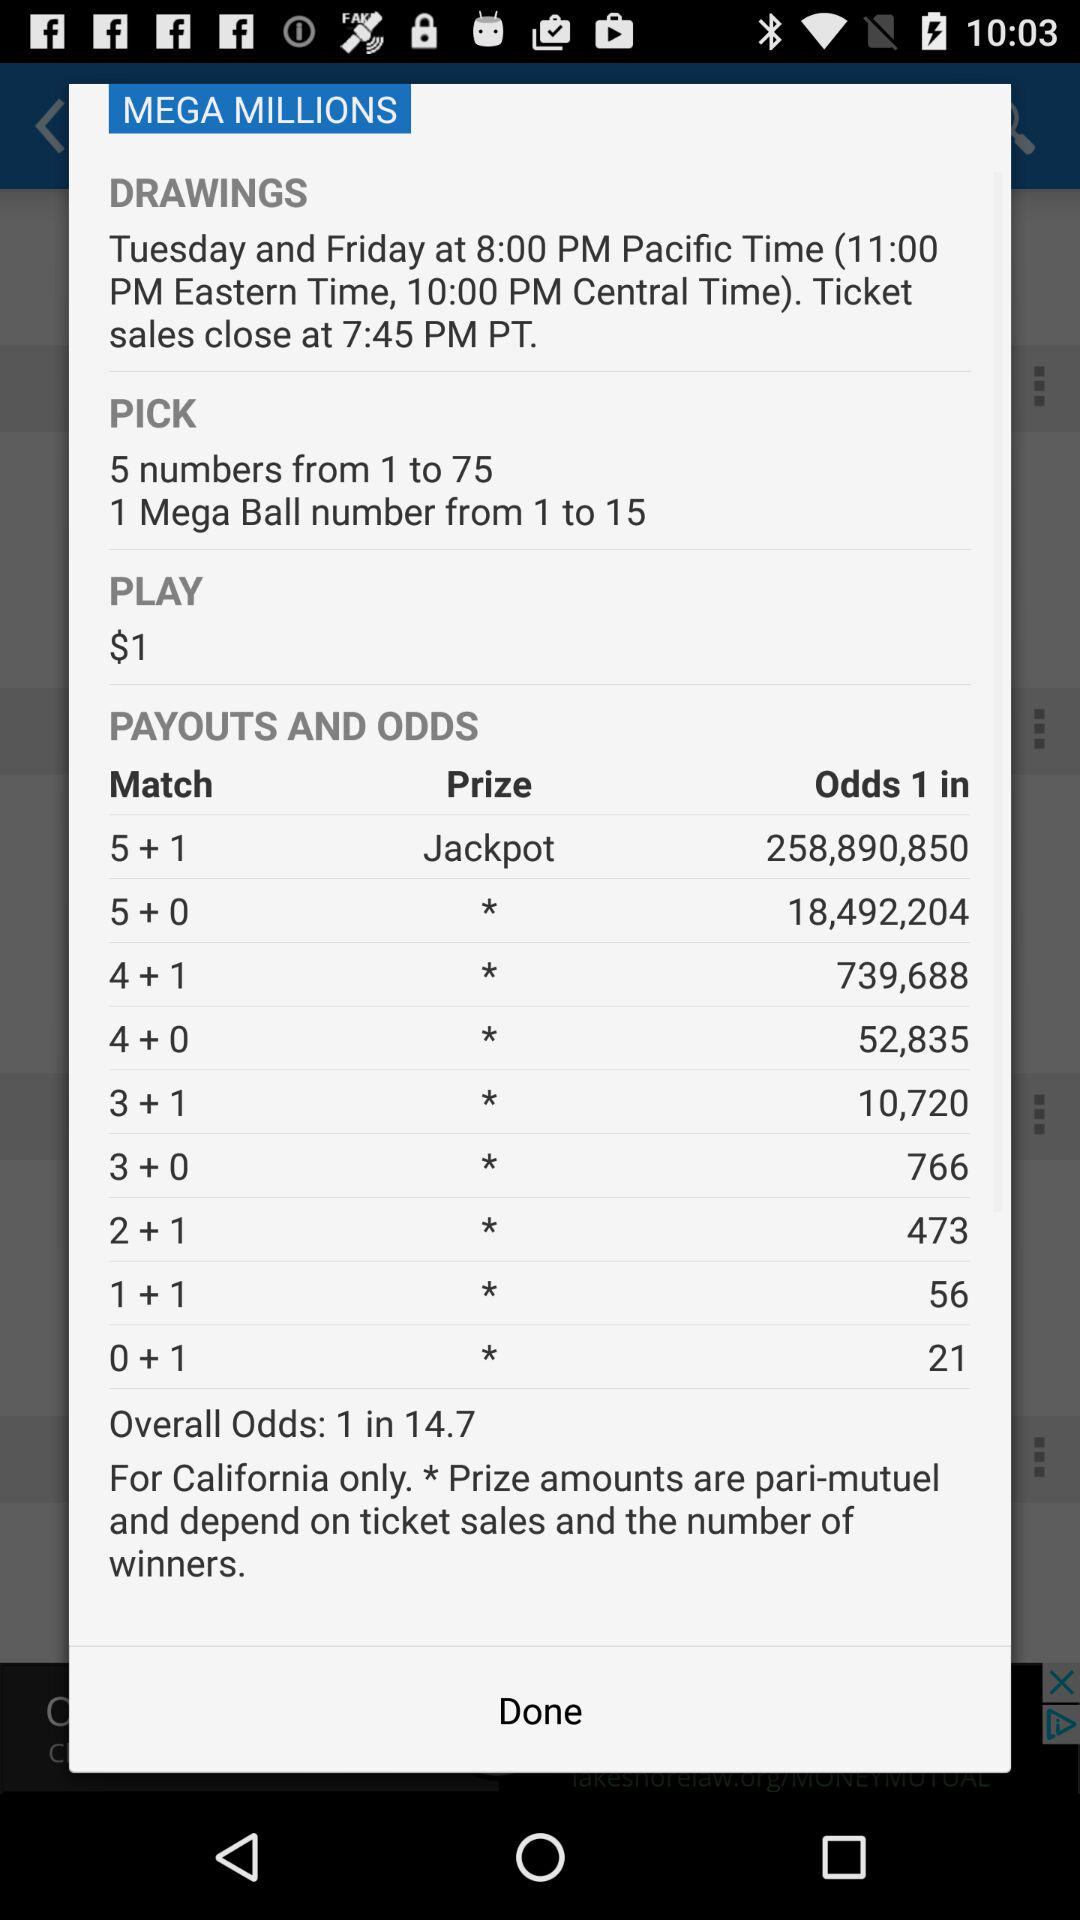What is the prize of the match "5+1"? The prize of the match "5+1" is "Jackpot". 